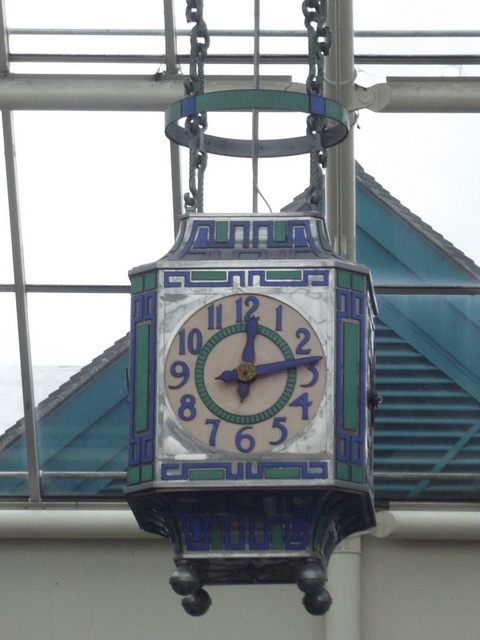Describe the objects in this image and their specific colors. I can see a clock in gray and blue tones in this image. 